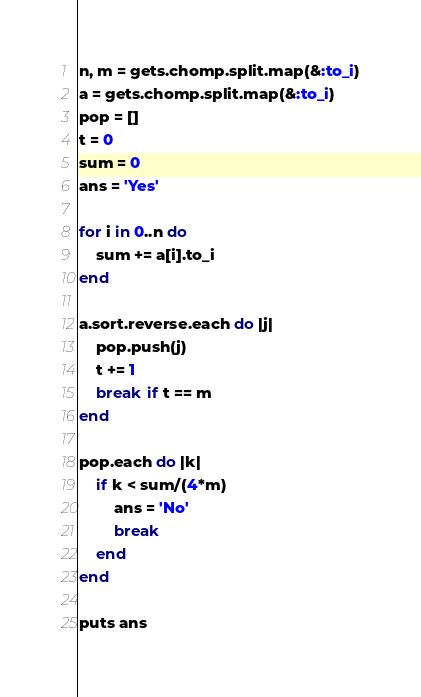Convert code to text. <code><loc_0><loc_0><loc_500><loc_500><_Ruby_>n, m = gets.chomp.split.map(&:to_i)
a = gets.chomp.split.map(&:to_i)
pop = []
t = 0
sum = 0
ans = 'Yes'

for i in 0..n do
    sum += a[i].to_i
end

a.sort.reverse.each do |j|
    pop.push(j)
    t += 1
    break if t == m
end

pop.each do |k|
    if k < sum/(4*m)
        ans = 'No'
        break
    end
end

puts ans</code> 